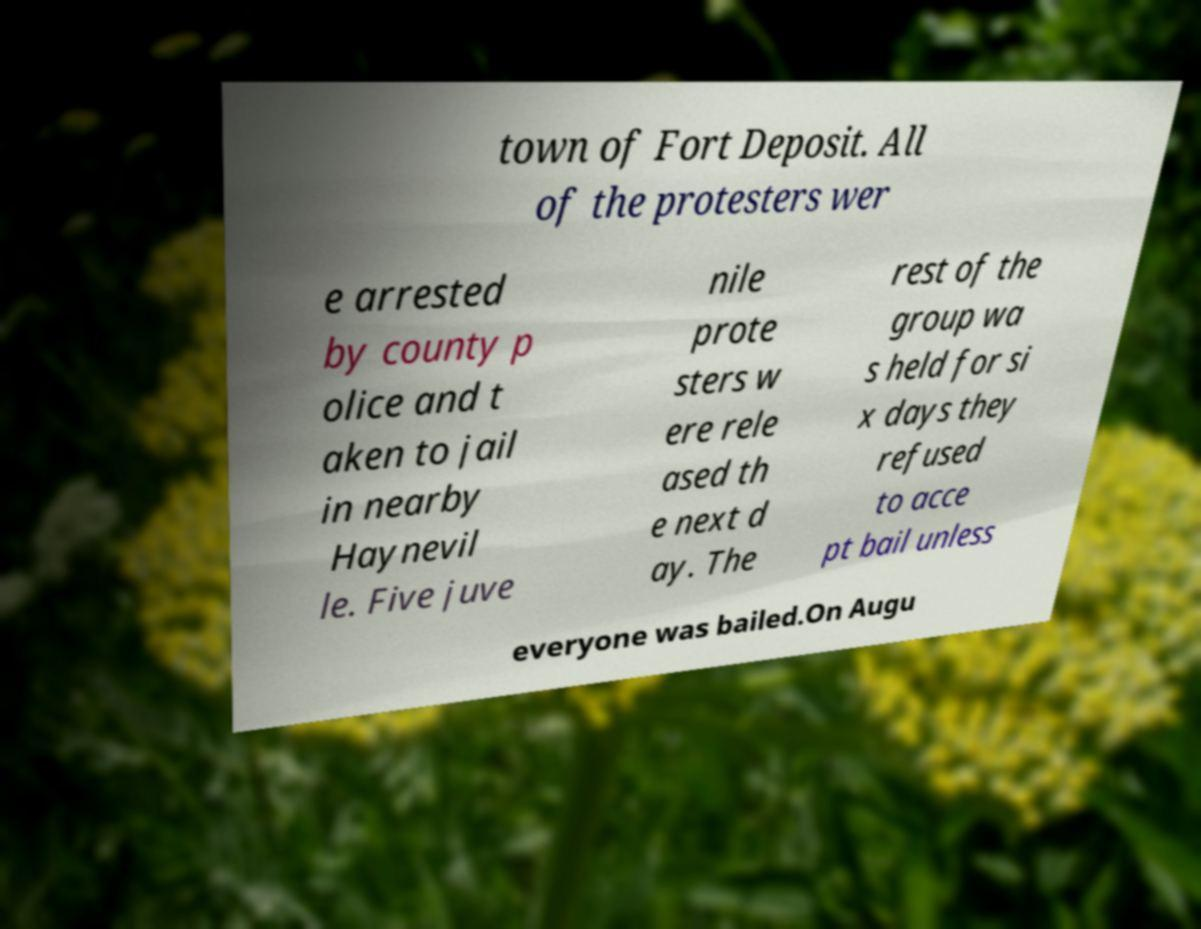I need the written content from this picture converted into text. Can you do that? town of Fort Deposit. All of the protesters wer e arrested by county p olice and t aken to jail in nearby Haynevil le. Five juve nile prote sters w ere rele ased th e next d ay. The rest of the group wa s held for si x days they refused to acce pt bail unless everyone was bailed.On Augu 